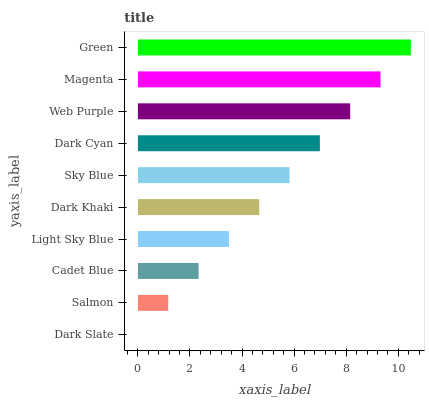Is Dark Slate the minimum?
Answer yes or no. Yes. Is Green the maximum?
Answer yes or no. Yes. Is Salmon the minimum?
Answer yes or no. No. Is Salmon the maximum?
Answer yes or no. No. Is Salmon greater than Dark Slate?
Answer yes or no. Yes. Is Dark Slate less than Salmon?
Answer yes or no. Yes. Is Dark Slate greater than Salmon?
Answer yes or no. No. Is Salmon less than Dark Slate?
Answer yes or no. No. Is Sky Blue the high median?
Answer yes or no. Yes. Is Dark Khaki the low median?
Answer yes or no. Yes. Is Dark Slate the high median?
Answer yes or no. No. Is Cadet Blue the low median?
Answer yes or no. No. 